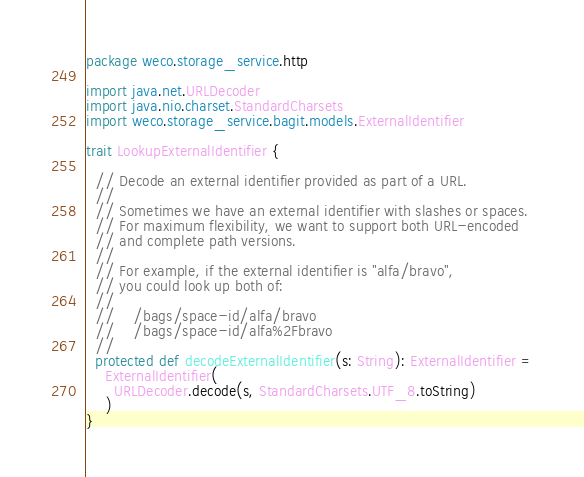Convert code to text. <code><loc_0><loc_0><loc_500><loc_500><_Scala_>package weco.storage_service.http

import java.net.URLDecoder
import java.nio.charset.StandardCharsets
import weco.storage_service.bagit.models.ExternalIdentifier

trait LookupExternalIdentifier {

  // Decode an external identifier provided as part of a URL.
  //
  // Sometimes we have an external identifier with slashes or spaces.
  // For maximum flexibility, we want to support both URL-encoded
  // and complete path versions.
  //
  // For example, if the external identifier is "alfa/bravo",
  // you could look up both of:
  //
  //    /bags/space-id/alfa/bravo
  //    /bags/space-id/alfa%2Fbravo
  //
  protected def decodeExternalIdentifier(s: String): ExternalIdentifier =
    ExternalIdentifier(
      URLDecoder.decode(s, StandardCharsets.UTF_8.toString)
    )
}
</code> 